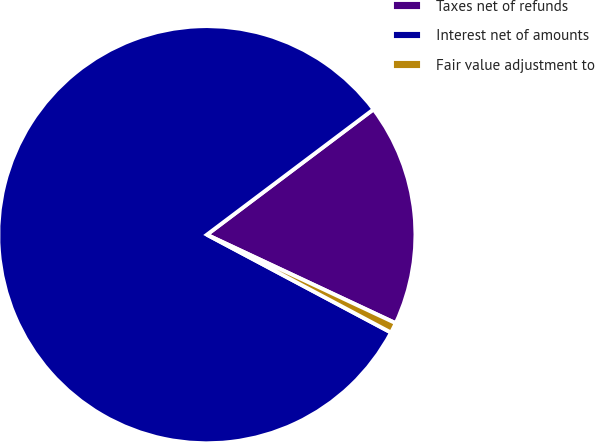<chart> <loc_0><loc_0><loc_500><loc_500><pie_chart><fcel>Taxes net of refunds<fcel>Interest net of amounts<fcel>Fair value adjustment to<nl><fcel>17.24%<fcel>81.96%<fcel>0.8%<nl></chart> 